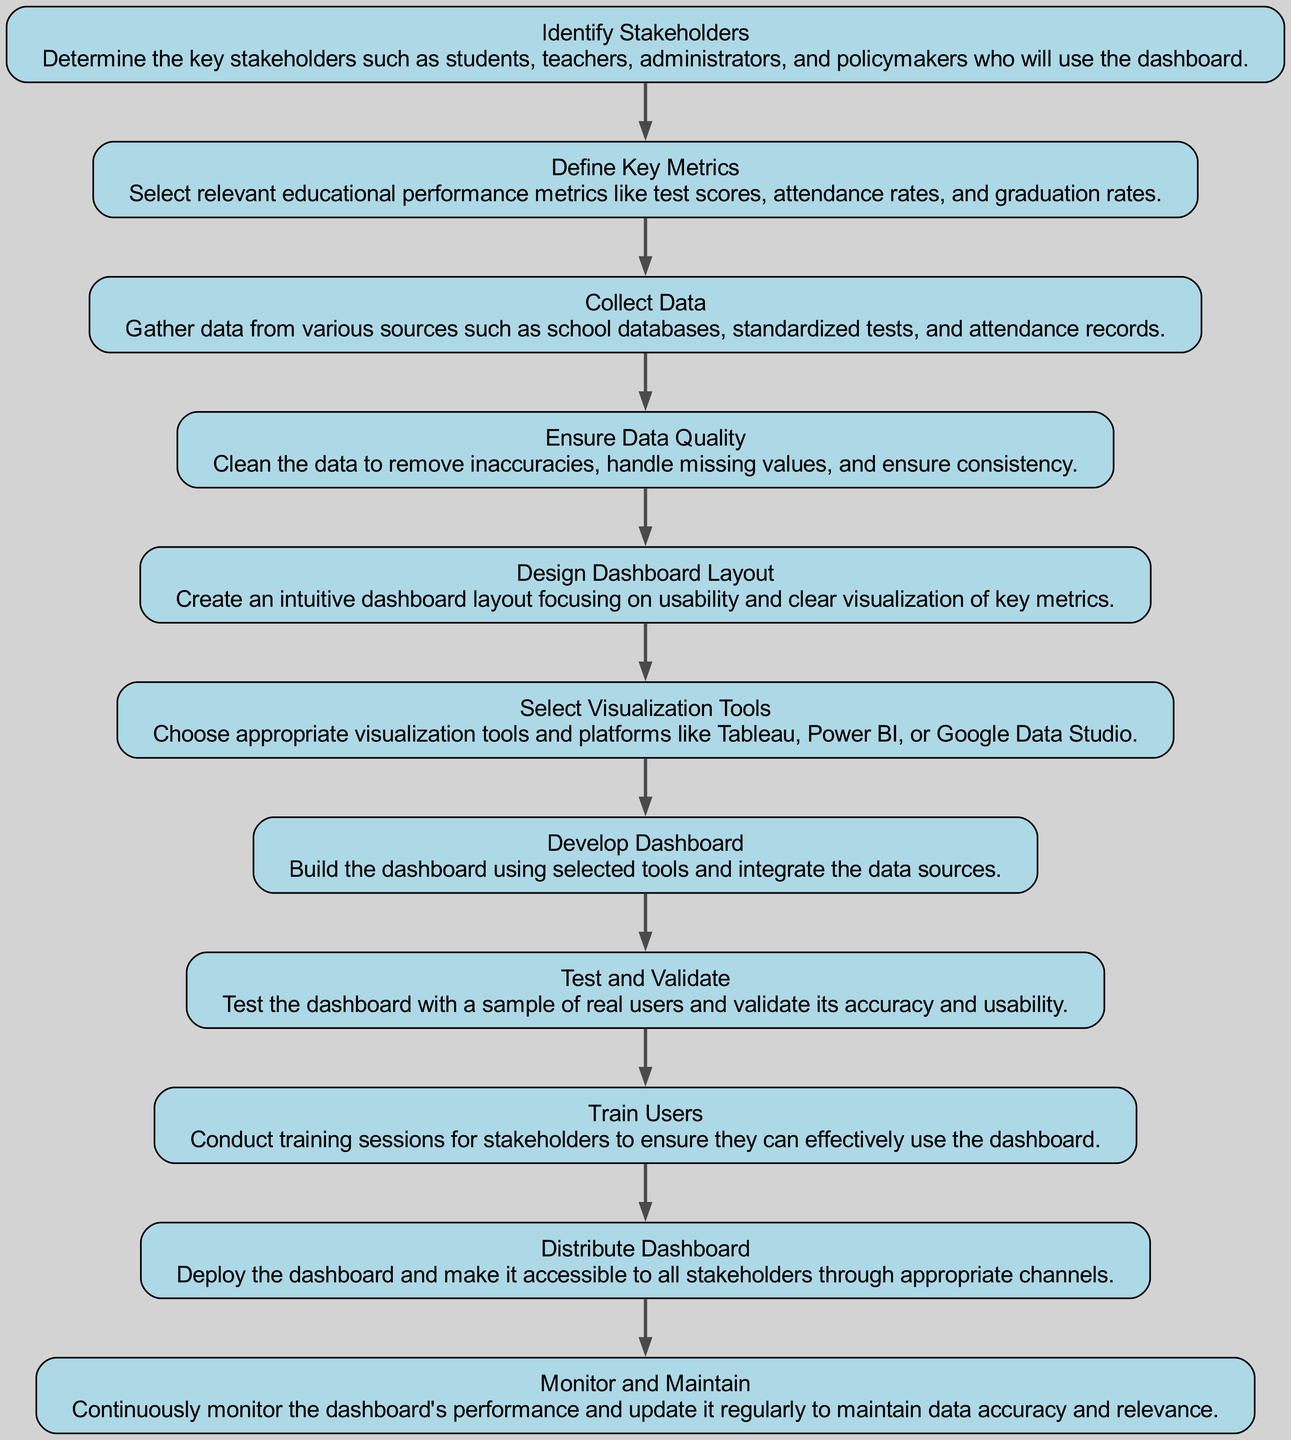What is the first step in developing the dashboard? The initial step in the flow chart is "Identify Stakeholders," indicating the need to determine key users of the dashboard.
Answer: Identify Stakeholders How many steps are in the development process? The diagram lists a total of eleven steps from identifying stakeholders to monitoring and maintaining the dashboard.
Answer: Eleven What is the last step in the process? The final step indicated in the flow chart is "Monitor and Maintain," which focuses on ongoing performance oversight and updates.
Answer: Monitor and Maintain Which step follows "Collect Data"? According to the flow chart, "Ensure Data Quality" directly follows "Collect Data," indicating a sequential workflow that emphasizes data management.
Answer: Ensure Data Quality What does the step "Train Users" focus on? This step emphasizes conducting training sessions for stakeholders, ensuring they know how to effectively use the dashboard for their needs.
Answer: Conduct training sessions How many steps involve the use of tools? In the diagram, there are two steps that mention the selection or development of tools: "Select Visualization Tools" and "Develop Dashboard." Therefore, the total is two.
Answer: Two What happens after "Test and Validate"? Following "Test and Validate," the next step in the flow is "Train Users," which suggests that user training occurs after the dashboard has been validated.
Answer: Train Users What is the key metric mentioned for defining metrics? One key metric illustrated in the diagram is "graduation rates," which is relevant to assessing educational performance within the dashboard.
Answer: Graduation rates What is the relationship between "Design Dashboard Layout" and "Develop Dashboard"? The relationship is sequential; after the "Design Dashboard Layout" step, the next action is to "Develop Dashboard," showing that the design is foundational for development.
Answer: Sequential relationship Which stakeholders are involved in the process? The stakeholders include students, teachers, administrators, and policymakers, as identified in the first step of the diagram.
Answer: Students, teachers, administrators, and policymakers 